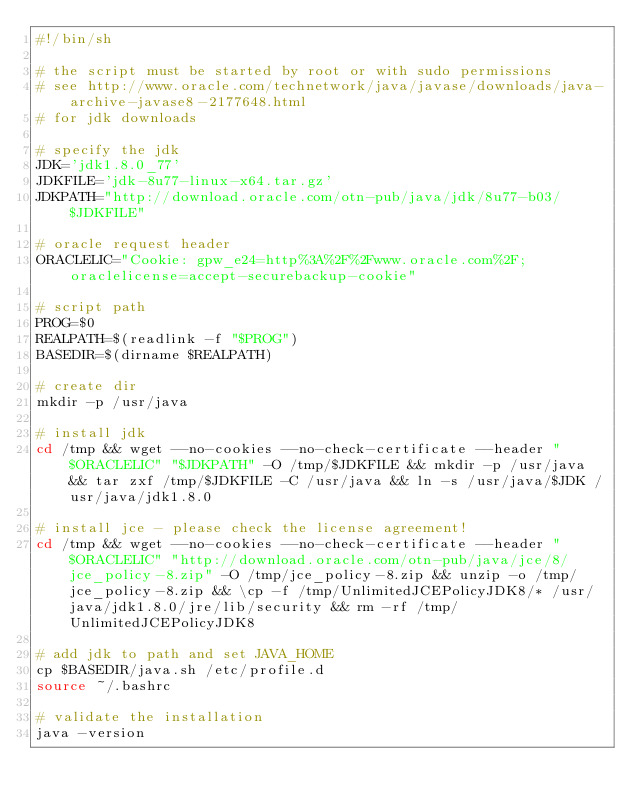<code> <loc_0><loc_0><loc_500><loc_500><_Bash_>#!/bin/sh

# the script must be started by root or with sudo permissions
# see http://www.oracle.com/technetwork/java/javase/downloads/java-archive-javase8-2177648.html
# for jdk downloads

# specify the jdk
JDK='jdk1.8.0_77'
JDKFILE='jdk-8u77-linux-x64.tar.gz'
JDKPATH="http://download.oracle.com/otn-pub/java/jdk/8u77-b03/$JDKFILE"

# oracle request header
ORACLELIC="Cookie: gpw_e24=http%3A%2F%2Fwww.oracle.com%2F; oraclelicense=accept-securebackup-cookie"

# script path
PROG=$0
REALPATH=$(readlink -f "$PROG")
BASEDIR=$(dirname $REALPATH)

# create dir
mkdir -p /usr/java

# install jdk
cd /tmp && wget --no-cookies --no-check-certificate --header "$ORACLELIC" "$JDKPATH" -O /tmp/$JDKFILE && mkdir -p /usr/java && tar zxf /tmp/$JDKFILE -C /usr/java && ln -s /usr/java/$JDK /usr/java/jdk1.8.0

# install jce - please check the license agreement!
cd /tmp && wget --no-cookies --no-check-certificate --header "$ORACLELIC" "http://download.oracle.com/otn-pub/java/jce/8/jce_policy-8.zip" -O /tmp/jce_policy-8.zip && unzip -o /tmp/jce_policy-8.zip && \cp -f /tmp/UnlimitedJCEPolicyJDK8/* /usr/java/jdk1.8.0/jre/lib/security && rm -rf /tmp/UnlimitedJCEPolicyJDK8

# add jdk to path and set JAVA_HOME
cp $BASEDIR/java.sh /etc/profile.d
source ~/.bashrc

# validate the installation
java -version
</code> 